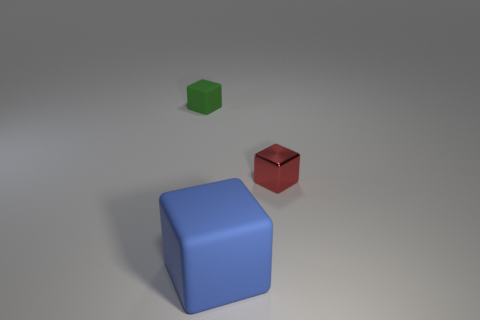Subtract 1 cubes. How many cubes are left? 2 Add 3 shiny cylinders. How many objects exist? 6 Add 3 tiny rubber objects. How many tiny rubber objects are left? 4 Add 3 red metallic objects. How many red metallic objects exist? 4 Subtract 0 red cylinders. How many objects are left? 3 Subtract all small cylinders. Subtract all small green matte cubes. How many objects are left? 2 